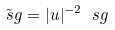Convert formula to latex. <formula><loc_0><loc_0><loc_500><loc_500>\tilde { \ s g } = | u | ^ { - 2 } \ s g</formula> 